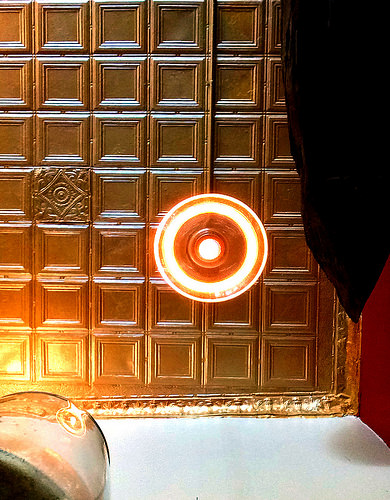<image>
Is the light bulb behind the tile? No. The light bulb is not behind the tile. From this viewpoint, the light bulb appears to be positioned elsewhere in the scene. 